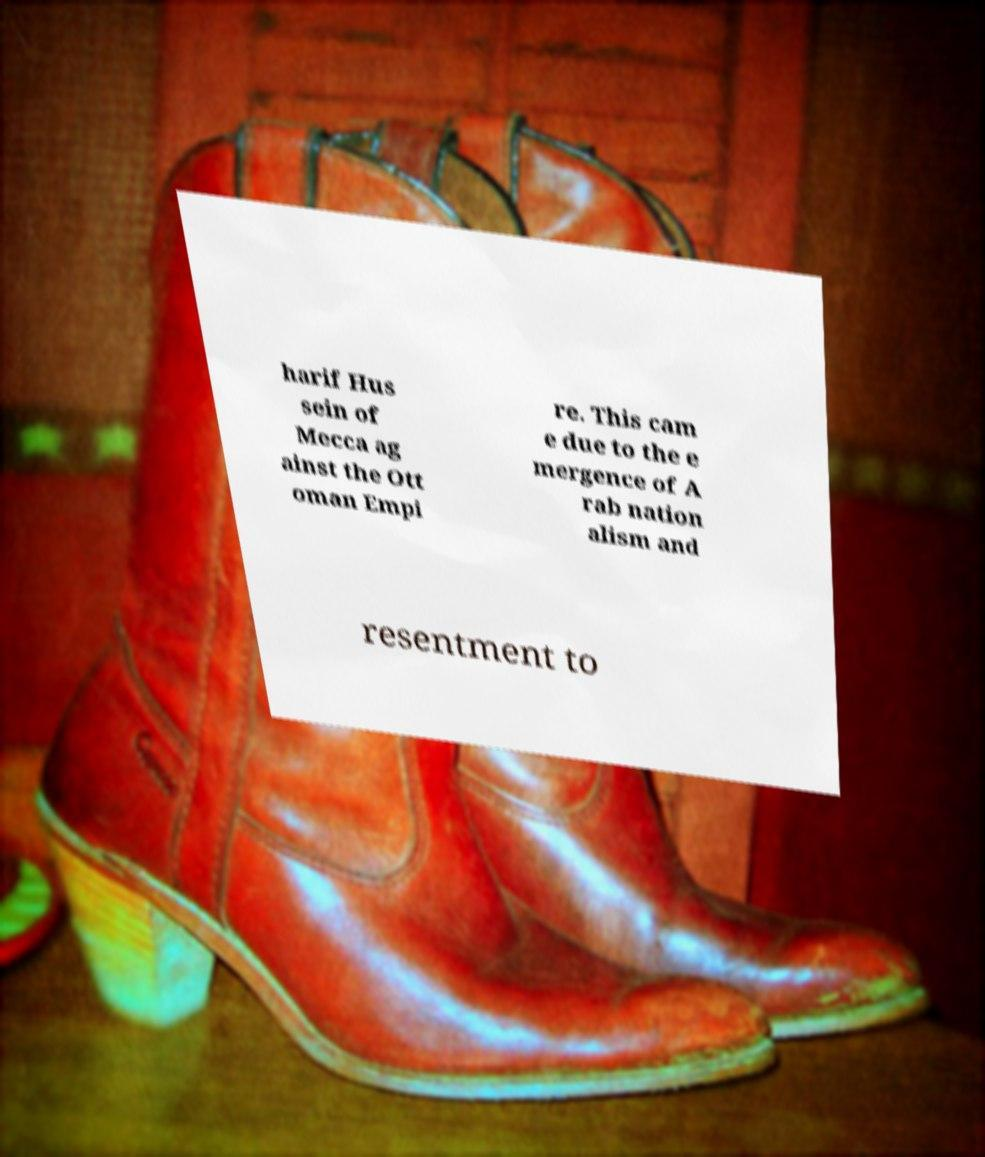What messages or text are displayed in this image? I need them in a readable, typed format. harif Hus sein of Mecca ag ainst the Ott oman Empi re. This cam e due to the e mergence of A rab nation alism and resentment to 